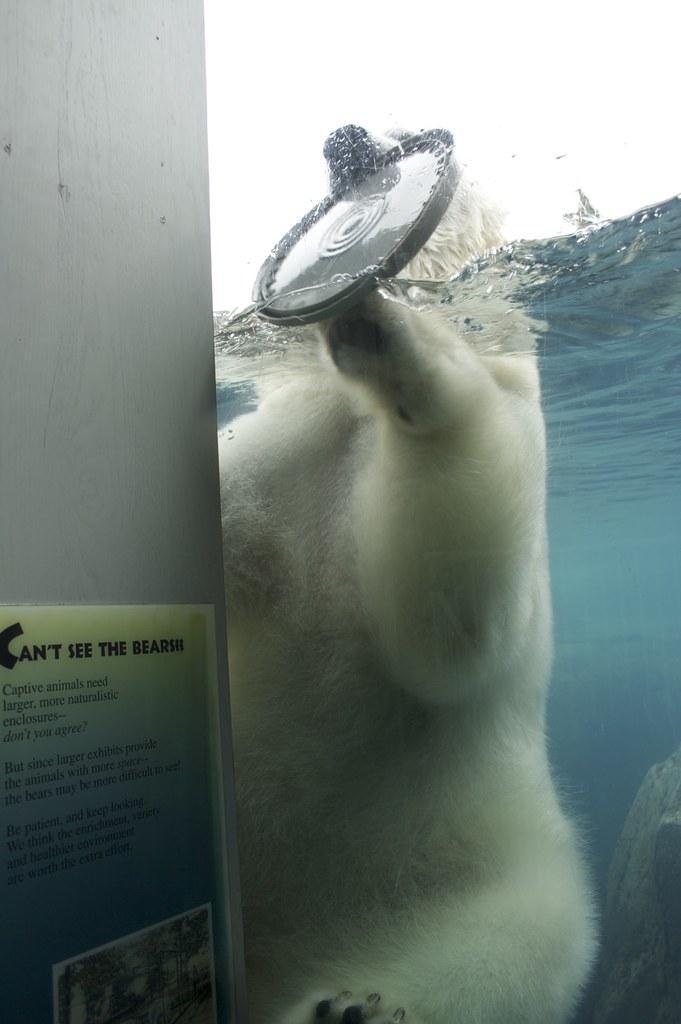Can you describe this image briefly? There is a polar bear in the water in the center of the image, by holding a disk like object in its jaws, it seems like a wall on the left side, on which there is a poster. 